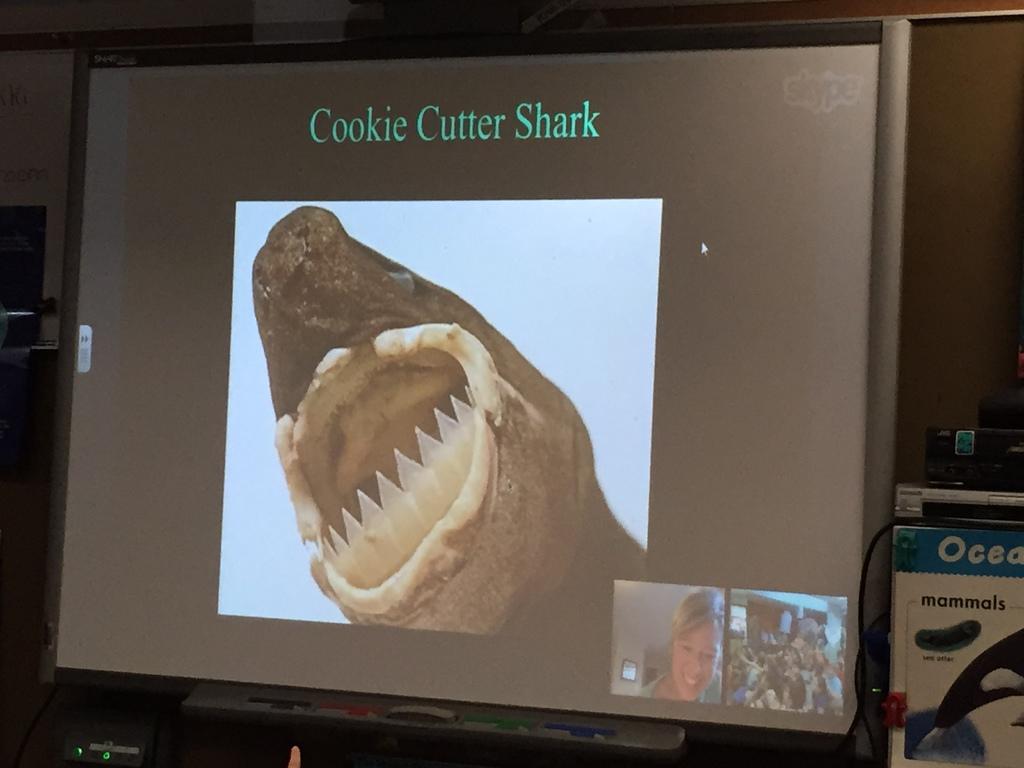What kind of shark is this?
Keep it short and to the point. Cookie cutter shark. Which animal is mentioned?
Give a very brief answer. Shark. 